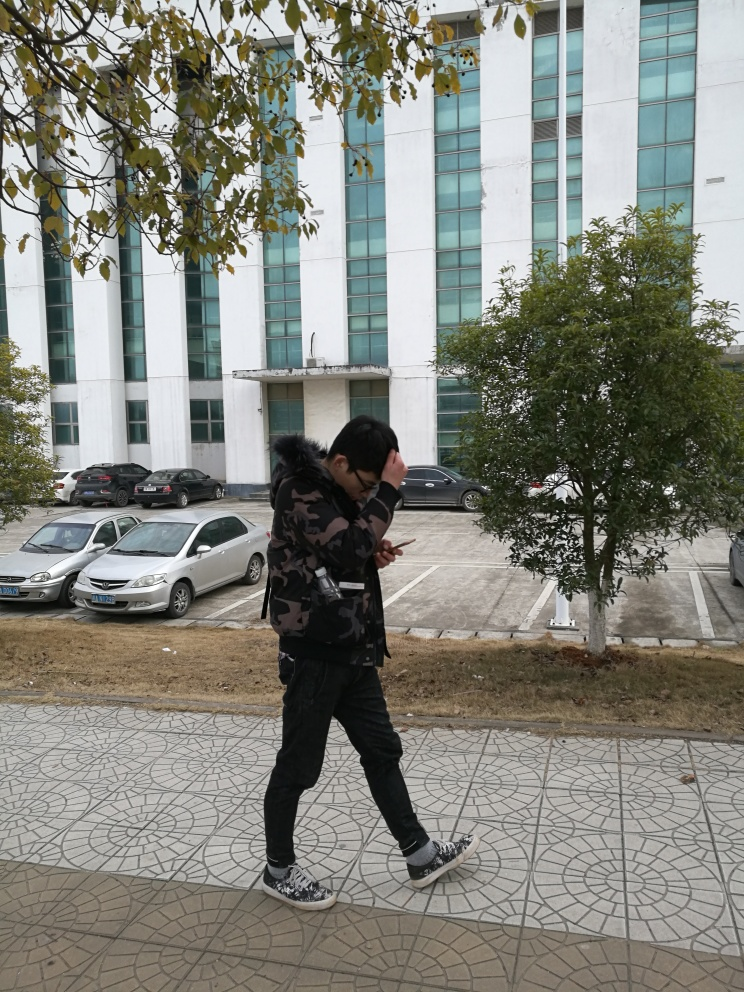What details can you notice about the clothing style of the person in the image? The person is wearing a casual, urban style of clothing. This includes a camouflage patterned jacket, dark pants, and sneakers with a distinctive design. The outfit looks comfortable and functional, suitable for everyday activities. 